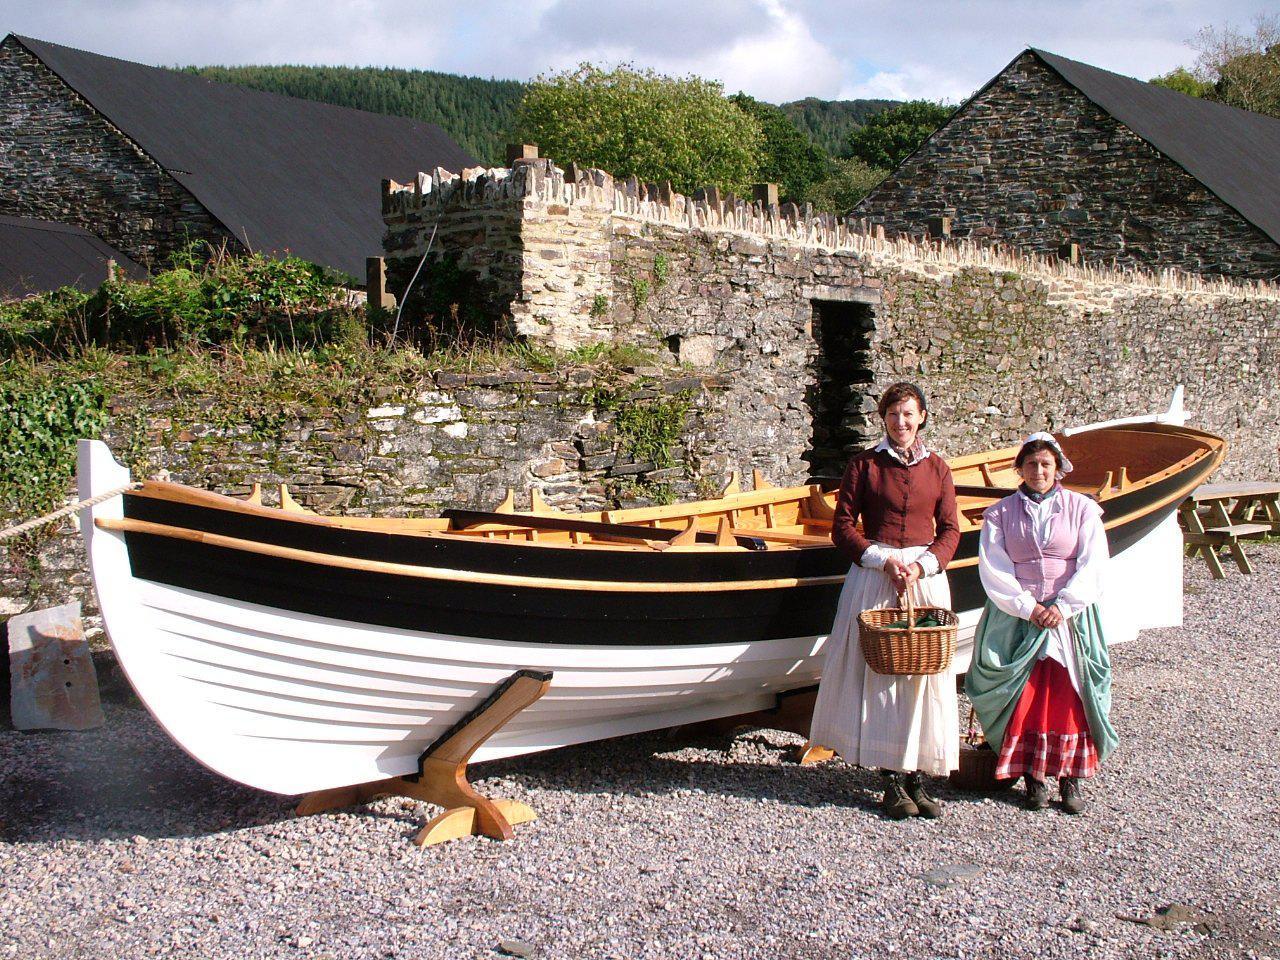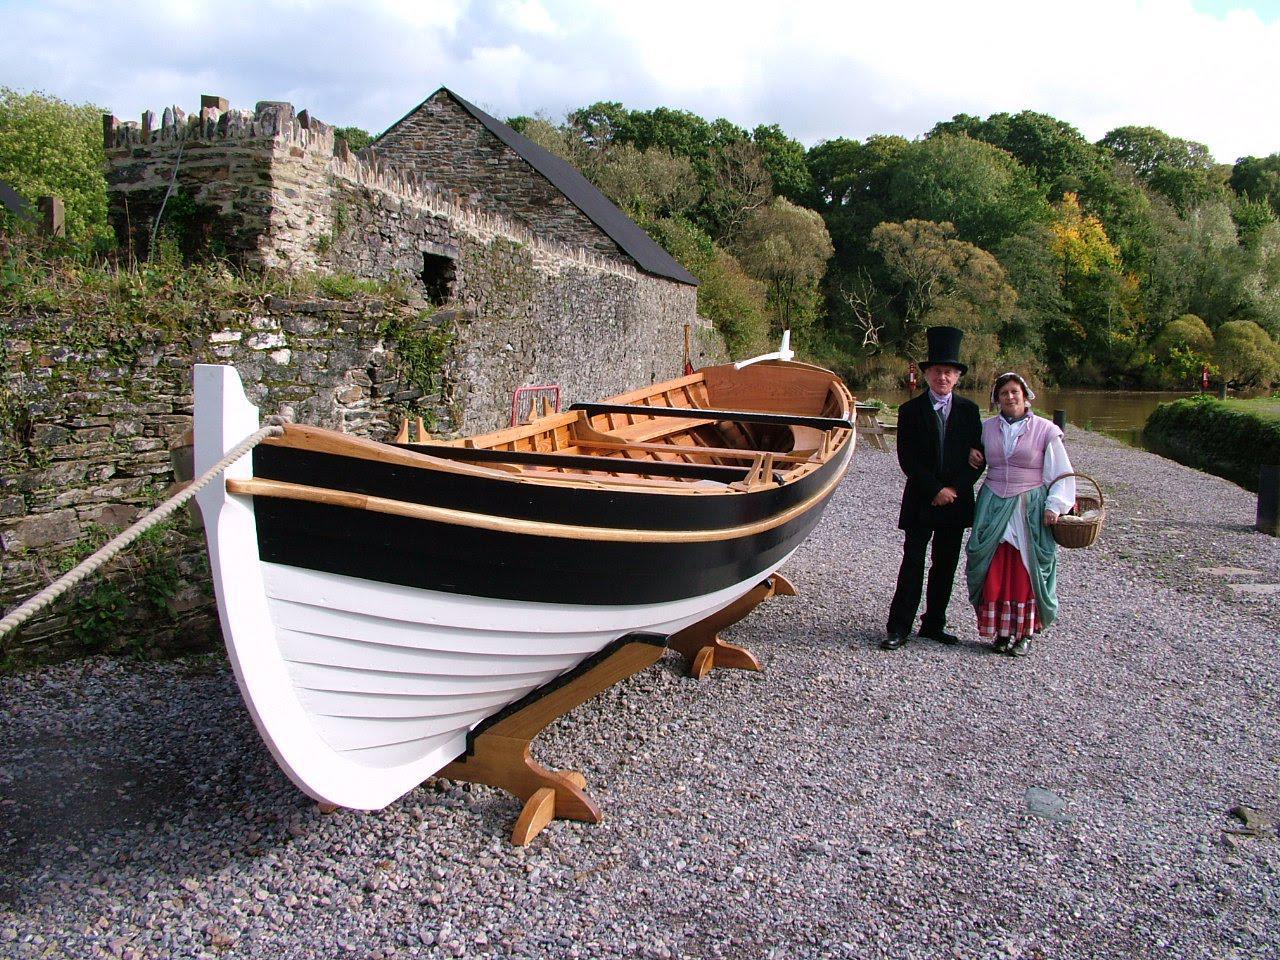The first image is the image on the left, the second image is the image on the right. Given the left and right images, does the statement "At least one image shows re-enactors, people wearing period clothing, on or near a boat." hold true? Answer yes or no. Yes. 